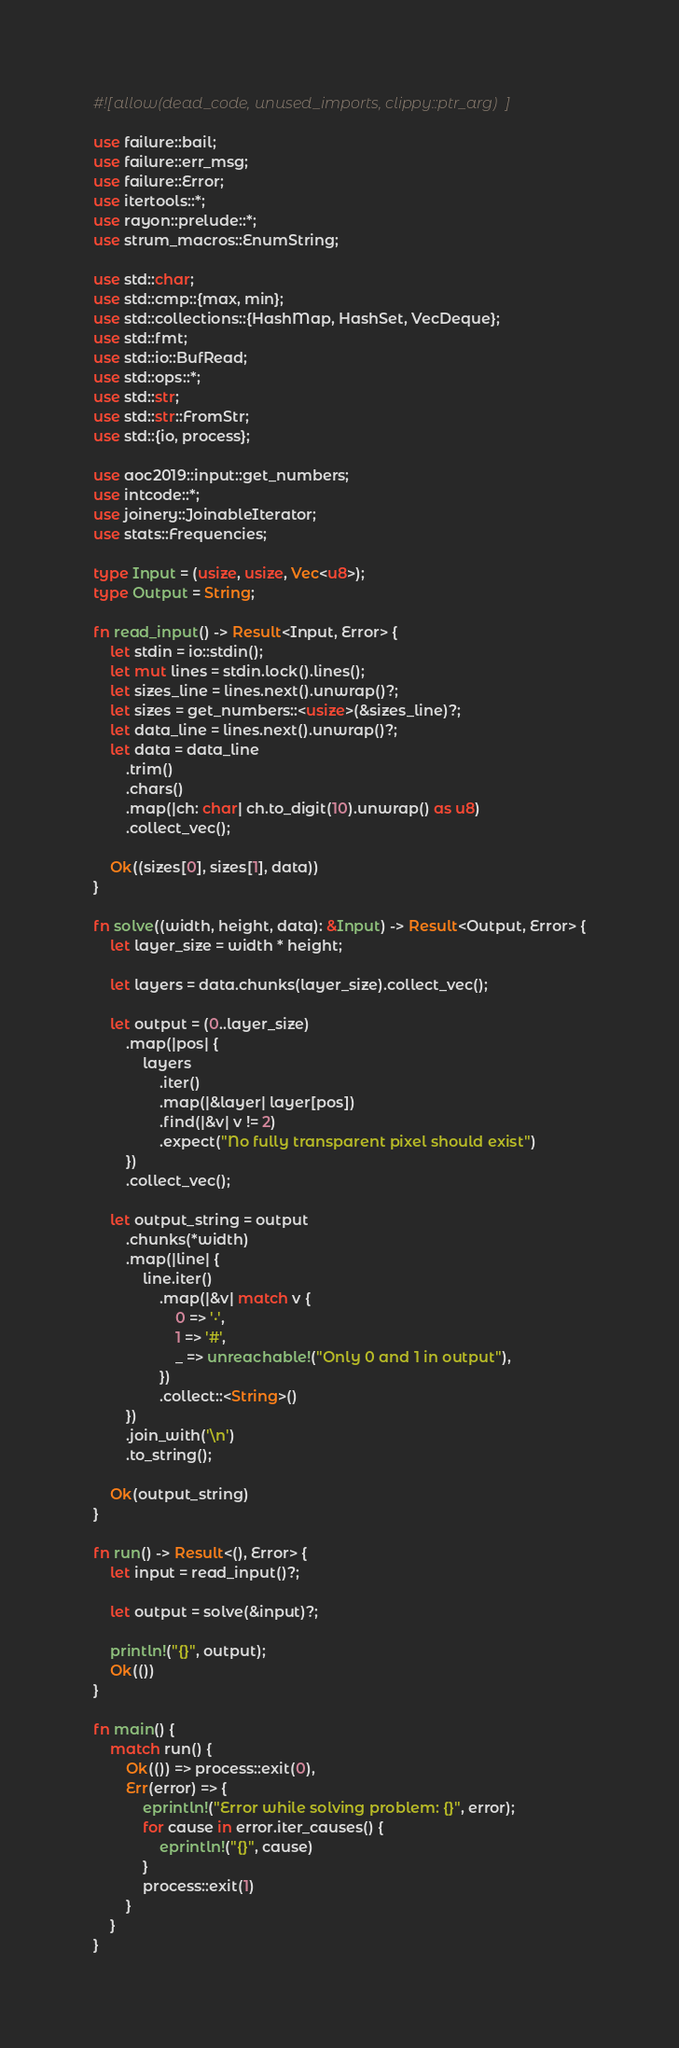<code> <loc_0><loc_0><loc_500><loc_500><_Rust_>#![allow(dead_code, unused_imports, clippy::ptr_arg)]

use failure::bail;
use failure::err_msg;
use failure::Error;
use itertools::*;
use rayon::prelude::*;
use strum_macros::EnumString;

use std::char;
use std::cmp::{max, min};
use std::collections::{HashMap, HashSet, VecDeque};
use std::fmt;
use std::io::BufRead;
use std::ops::*;
use std::str;
use std::str::FromStr;
use std::{io, process};

use aoc2019::input::get_numbers;
use intcode::*;
use joinery::JoinableIterator;
use stats::Frequencies;

type Input = (usize, usize, Vec<u8>);
type Output = String;

fn read_input() -> Result<Input, Error> {
    let stdin = io::stdin();
    let mut lines = stdin.lock().lines();
    let sizes_line = lines.next().unwrap()?;
    let sizes = get_numbers::<usize>(&sizes_line)?;
    let data_line = lines.next().unwrap()?;
    let data = data_line
        .trim()
        .chars()
        .map(|ch: char| ch.to_digit(10).unwrap() as u8)
        .collect_vec();

    Ok((sizes[0], sizes[1], data))
}

fn solve((width, height, data): &Input) -> Result<Output, Error> {
    let layer_size = width * height;

    let layers = data.chunks(layer_size).collect_vec();

    let output = (0..layer_size)
        .map(|pos| {
            layers
                .iter()
                .map(|&layer| layer[pos])
                .find(|&v| v != 2)
                .expect("No fully transparent pixel should exist")
        })
        .collect_vec();

    let output_string = output
        .chunks(*width)
        .map(|line| {
            line.iter()
                .map(|&v| match v {
                    0 => '·',
                    1 => '#',
                    _ => unreachable!("Only 0 and 1 in output"),
                })
                .collect::<String>()
        })
        .join_with('\n')
        .to_string();

    Ok(output_string)
}

fn run() -> Result<(), Error> {
    let input = read_input()?;

    let output = solve(&input)?;

    println!("{}", output);
    Ok(())
}

fn main() {
    match run() {
        Ok(()) => process::exit(0),
        Err(error) => {
            eprintln!("Error while solving problem: {}", error);
            for cause in error.iter_causes() {
                eprintln!("{}", cause)
            }
            process::exit(1)
        }
    }
}
</code> 